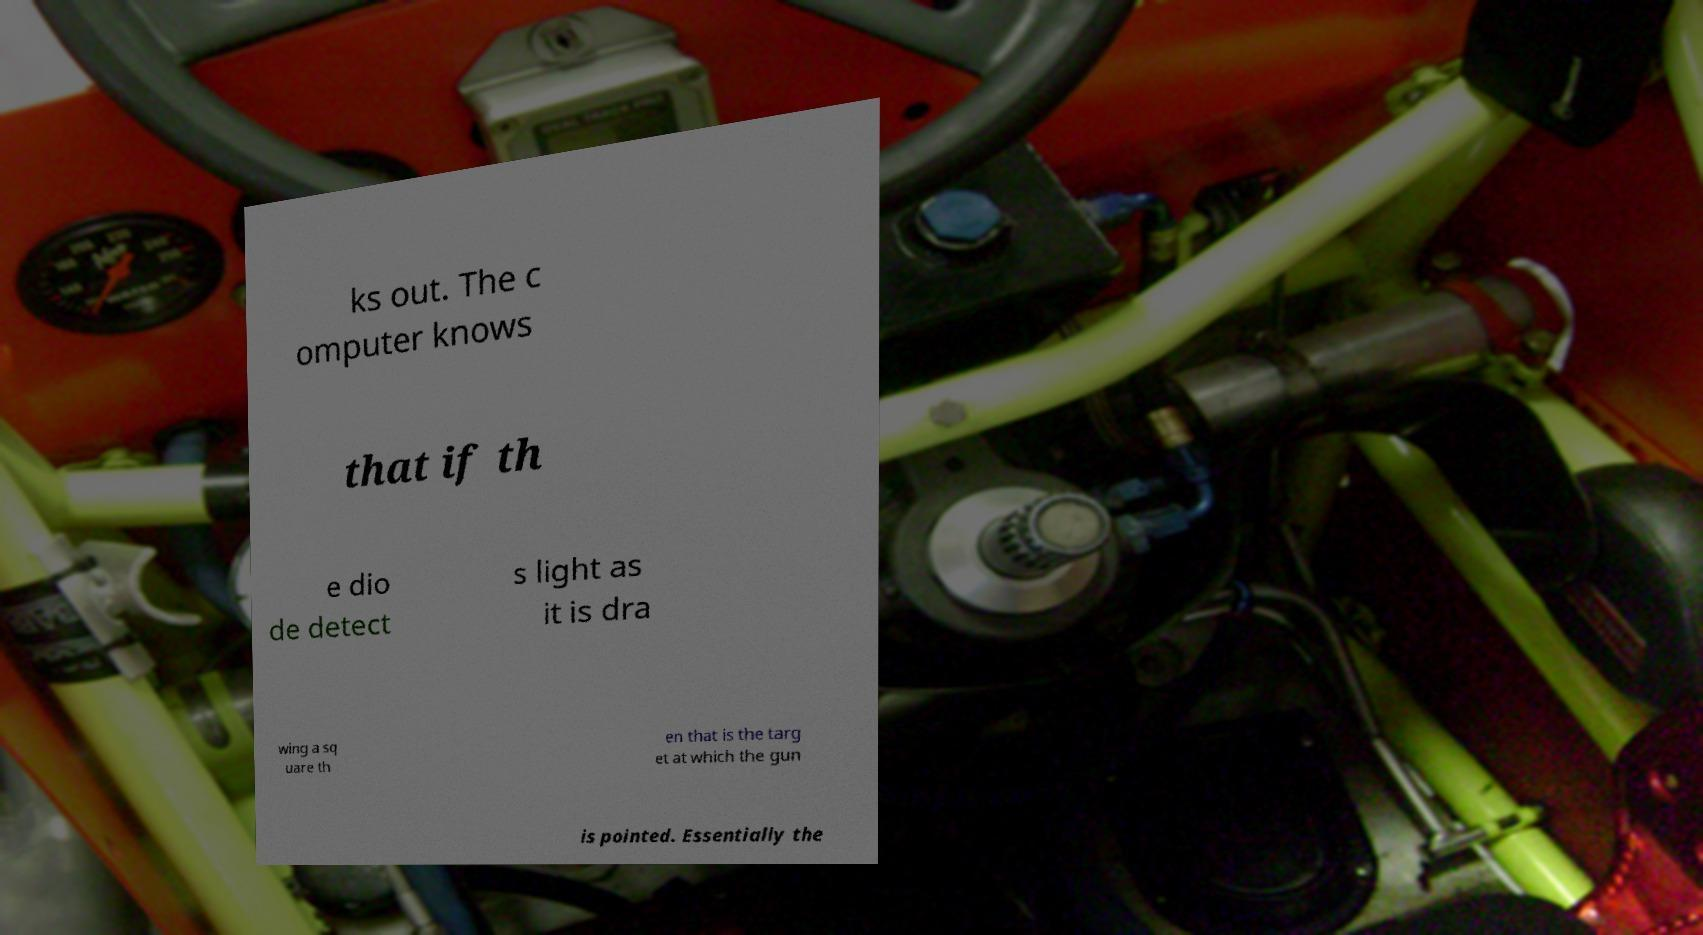Can you read and provide the text displayed in the image?This photo seems to have some interesting text. Can you extract and type it out for me? ks out. The c omputer knows that if th e dio de detect s light as it is dra wing a sq uare th en that is the targ et at which the gun is pointed. Essentially the 